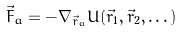Convert formula to latex. <formula><loc_0><loc_0><loc_500><loc_500>\vec { F } _ { a } = - \nabla _ { \vec { r } _ { a } } U ( \vec { r } _ { 1 } , \vec { r } _ { 2 } , \dots )</formula> 